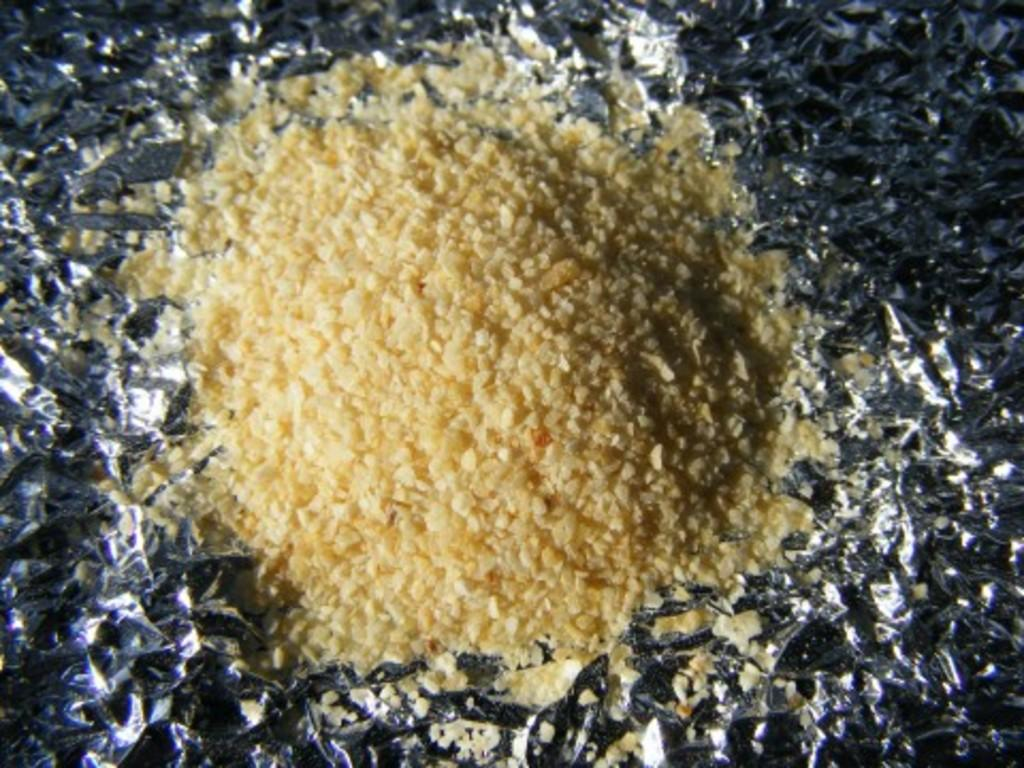What is the main subject of the image? There is a food item in the image. How is the food item presented? The food item is on a silver paper. What month is depicted in the image? There is no month depicted in the image; it features a food item on a silver paper. What scientific principle is demonstrated in the image? There is no scientific principle demonstrated in the image; it features a food item on a silver paper. 